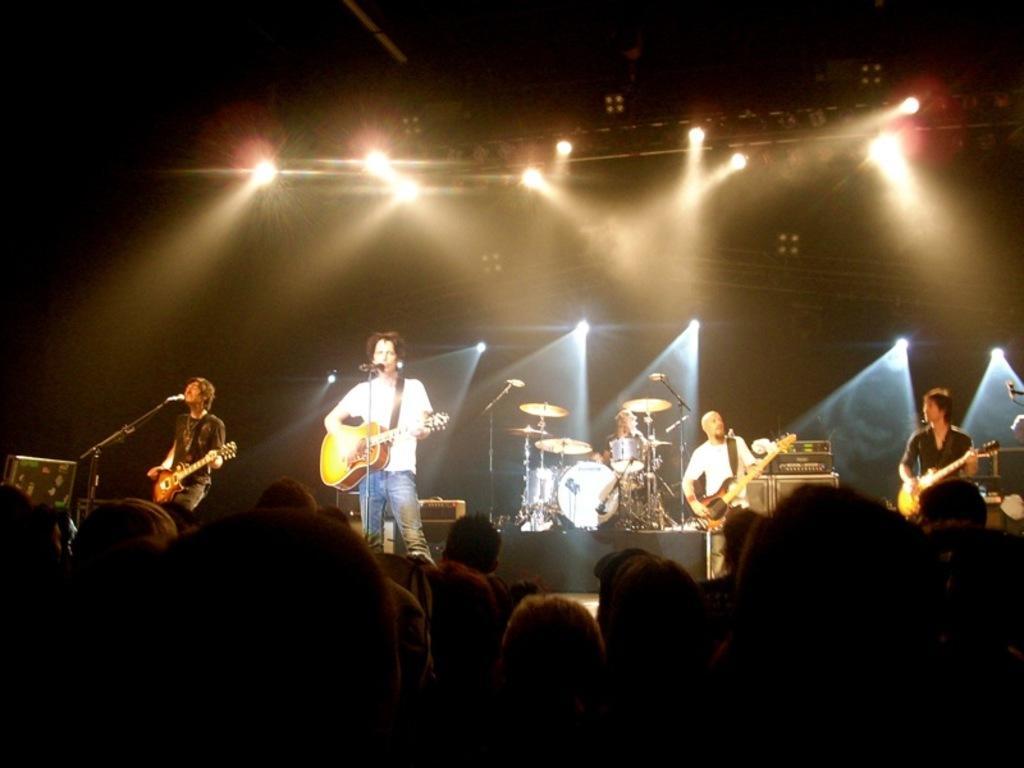Please provide a concise description of this image. This picture is clicked in a musical concert. Here, we see four people standing and holding guitar in their hands and playing it and they are even singing on microphone. Behind them, we see a man in black shirt is playing drums. In front of them, we see many people enjoying that music. 